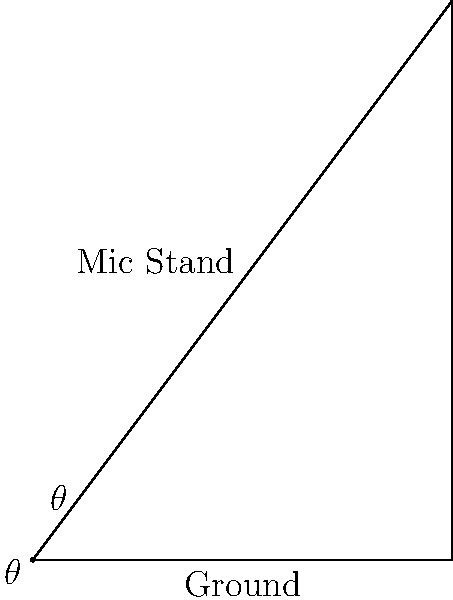At a Three 6 Mafia reunion concert, you notice the microphone stand is tilted at an angle. If the base of the stand is 3 feet long and the top of the mic is 4 feet high, what is the angle of inclination ($\theta$) of the microphone stand? Let's approach this step-by-step:

1) We can see that the microphone stand, its base, and the vertical line from the top of the mic to the ground form a right-angled triangle.

2) We're looking for the angle $\theta$, which is the angle of inclination of the mic stand.

3) We know:
   - The base (adjacent side to $\theta$) is 3 feet
   - The height (opposite side to $\theta$) is 4 feet

4) To find $\theta$, we can use the tangent function:

   $$\tan(\theta) = \frac{\text{opposite}}{\text{adjacent}} = \frac{4}{3}$$

5) To get $\theta$, we need to take the inverse tangent (arctan or $\tan^{-1}$):

   $$\theta = \tan^{-1}(\frac{4}{3})$$

6) Using a calculator or trigonometric tables:

   $$\theta \approx 53.13^\circ$$

7) Rounding to the nearest degree:

   $$\theta \approx 53^\circ$$
Answer: 53° 